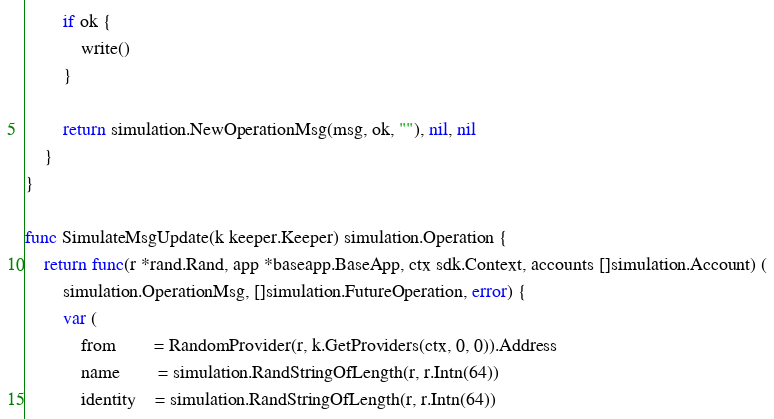Convert code to text. <code><loc_0><loc_0><loc_500><loc_500><_Go_>		if ok {
			write()
		}

		return simulation.NewOperationMsg(msg, ok, ""), nil, nil
	}
}

func SimulateMsgUpdate(k keeper.Keeper) simulation.Operation {
	return func(r *rand.Rand, app *baseapp.BaseApp, ctx sdk.Context, accounts []simulation.Account) (
		simulation.OperationMsg, []simulation.FutureOperation, error) {
		var (
			from        = RandomProvider(r, k.GetProviders(ctx, 0, 0)).Address
			name        = simulation.RandStringOfLength(r, r.Intn(64))
			identity    = simulation.RandStringOfLength(r, r.Intn(64))</code> 